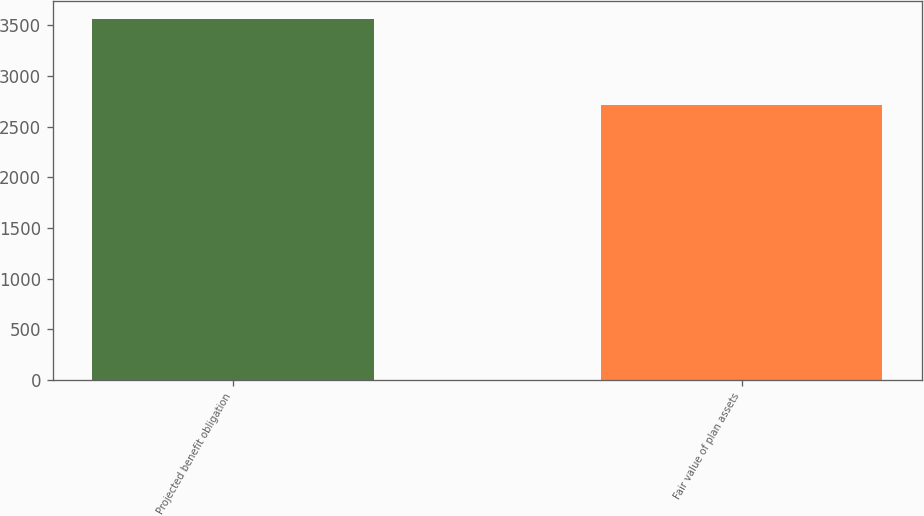Convert chart to OTSL. <chart><loc_0><loc_0><loc_500><loc_500><bar_chart><fcel>Projected benefit obligation<fcel>Fair value of plan assets<nl><fcel>3559<fcel>2711<nl></chart> 